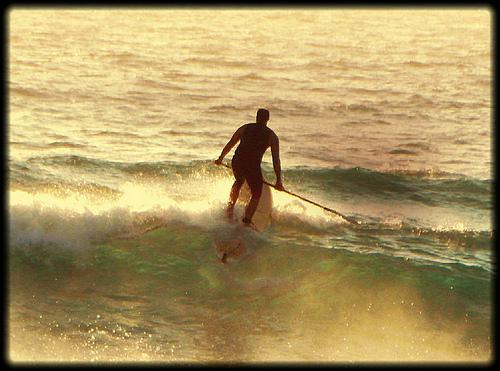Question: what is he doing?
Choices:
A. Reading.
B. Surfing.
C. Swimming.
D. Riding a bike.
Answer with the letter. Answer: B Question: why hold a paddle?
Choices:
A. For balance.
B. For the picture.
C. To control the board.
D. To move the boat.
Answer with the letter. Answer: C Question: who is taking the photo?
Choices:
A. The father.
B. The mother.
C. The girl.
D. A person on the beach.
Answer with the letter. Answer: D Question: what is he standing on?
Choices:
A. A stool.
B. A surfboard.
C. Porch.
D. Floor.
Answer with the letter. Answer: B Question: what time of day is it?
Choices:
A. Morning.
B. Afternoon.
C. Evening.
D. Sunrise.
Answer with the letter. Answer: B 